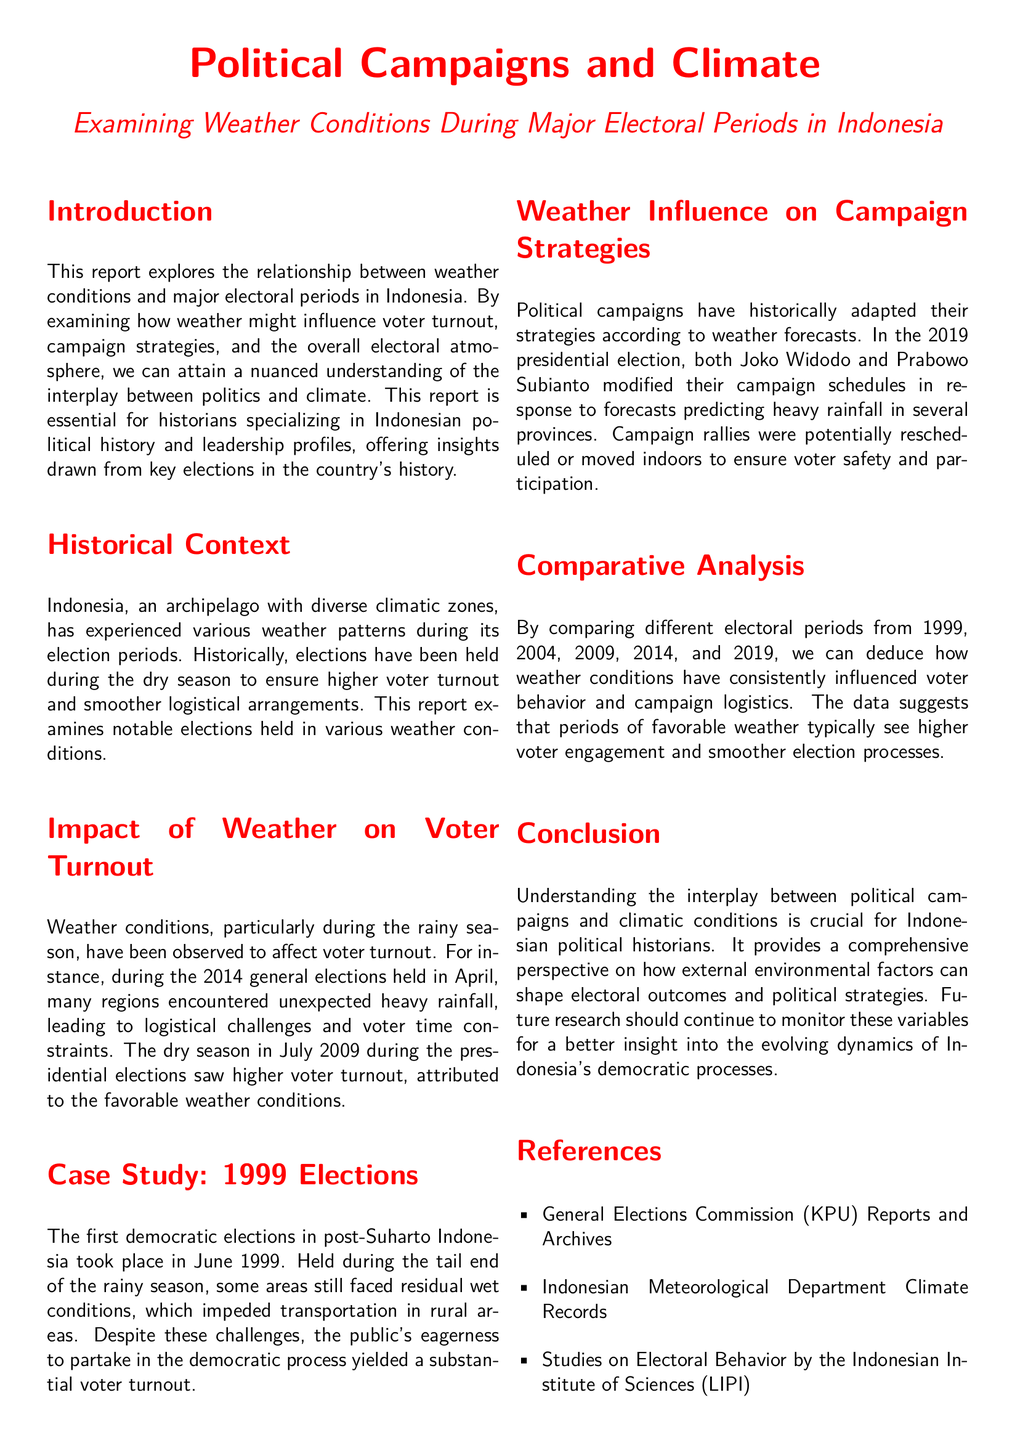What is the title of the report? The title of the report is clearly stated at the top of the document, which is "Political Campaigns and Climate."
Answer: Political Campaigns and Climate Which year did the first democratic elections take place in Indonesia? The document states that the first democratic elections in post-Suharto Indonesia occurred in June 1999.
Answer: 1999 What weather season is mentioned as influencing higher voter turnout? The report discusses the dry season in July 2009 during the presidential elections, attributing higher voter turnout to favorable weather conditions.
Answer: Dry season What significant event occurred during the 2014 general elections? The report highlights that unexpected heavy rainfall affected logistics and voter participation.
Answer: Heavy rainfall In which election did campaign strategies adapt due to weather forecasts? The document specifically refers to the 2019 presidential election, where both candidates modified their campaign schedules.
Answer: 2019 What influence does weather have according to the report? The analysis indicates that weather conditions consistently affect voter behavior and campaign logistics during electoral periods.
Answer: Voter behavior Which institution's reports are listed as references in the document? The report mentions the General Elections Commission (KPU) Reports and Archives as one of the references.
Answer: General Elections Commission (KPU) What is the focus of the report's analysis? It aims to understand the relationship between weather conditions and electoral periods, specifically their impact on various aspects of elections.
Answer: Weather and electoral periods What climatic event is noted in the case study of the 1999 elections? The case study notes that the elections were held during the tail end of the rainy season.
Answer: Tail end of the rainy season 